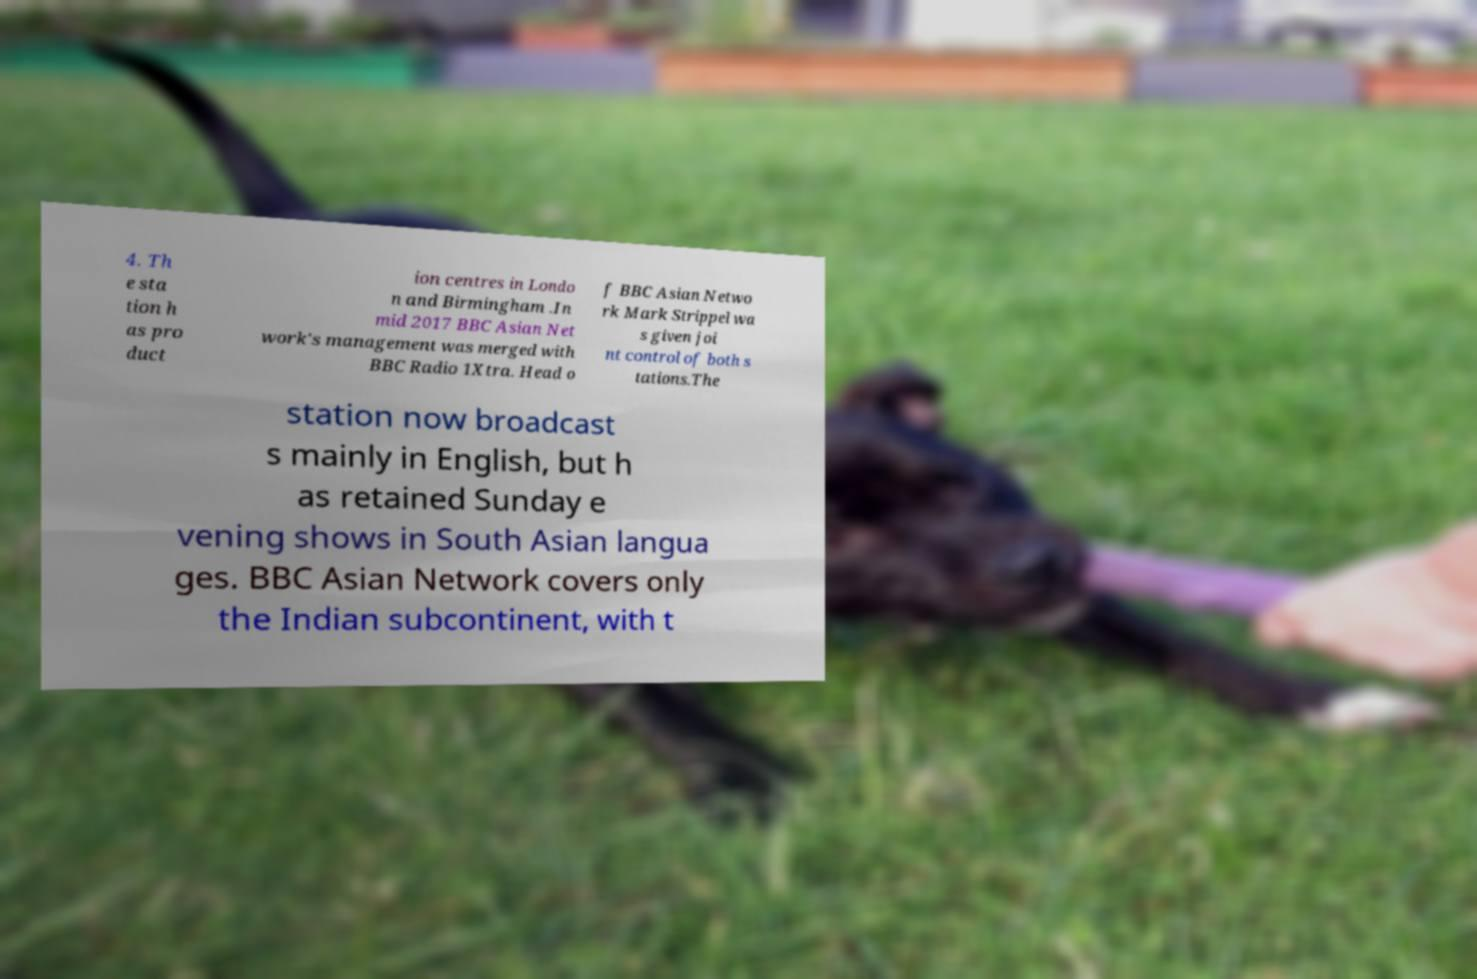Please read and relay the text visible in this image. What does it say? 4. Th e sta tion h as pro duct ion centres in Londo n and Birmingham .In mid 2017 BBC Asian Net work's management was merged with BBC Radio 1Xtra. Head o f BBC Asian Netwo rk Mark Strippel wa s given joi nt control of both s tations.The station now broadcast s mainly in English, but h as retained Sunday e vening shows in South Asian langua ges. BBC Asian Network covers only the Indian subcontinent, with t 